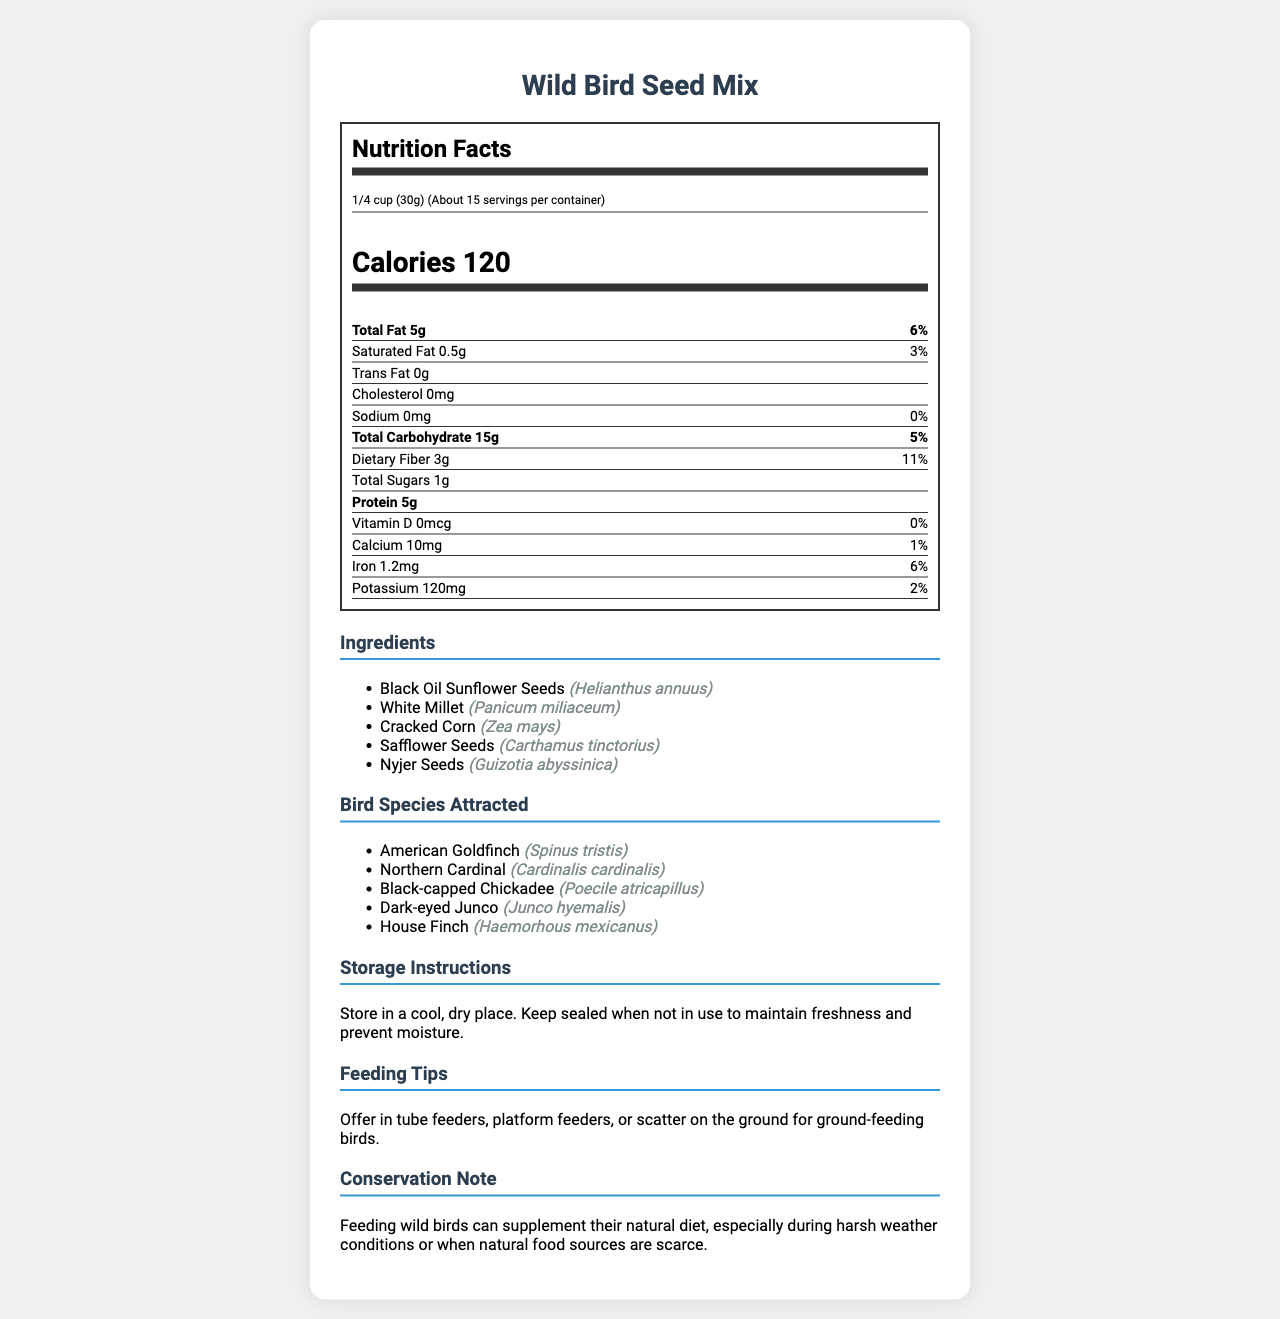what is the serving size of the Wild Bird Seed Mix? The serving size is listed at the top of the nutrition facts section.
Answer: 1/4 cup (30g) how many calories are in one serving? The calorie information is prominently displayed below the serving size and servings per container.
Answer: 120 what is the total fat content per serving? The total fat content is listed in the nutrition facts section under the calories.
Answer: 5g which ingredient is botanically known as Helianthus annuus? The scientific name Helianthus annuus corresponds to Black Oil Sunflower Seeds in the ingredients list.
Answer: Black Oil Sunflower Seeds how much protein does each serving contain? The protein content is listed towards the bottom of the nutrition facts section.
Answer: 5g which bird species is known scientifically as Spinus tristis? A. Northern Cardinal B. Dark-eyed Junco C. American Goldfinch D. House Finch The bird species section lists Spinus tristis as the scientific name for the American Goldfinch.
Answer: C. American Goldfinch how many milligrams of calcium are there per serving?  A. 10mg B. 15mg C. 20mg D. 25mg The calcium content is listed under the nutrition facts and is 10mg per serving.
Answer: A. 10mg does this bird seed mix attract Northern Cardinals? The bird species list includes Northern Cardinal with the scientific name Cardinalis cardinalis.
Answer: Yes describe the main idea of this document This document contains nutrition facts, serving size, ingredients list with scientific names, bird species attracted with scientific names, and usage instructions.
Answer: The main idea of the document is to provide an overview of the nutritional content, ingredients, bird species attracted, and usage instructions for the Wild Bird Seed Mix. which nutrient has the highest daily value percentage? The nutrient with the highest daily value percentage is listed under dietary fiber in the nutrition facts section.
Answer: Dietary Fiber (11%) what percentage of daily iron does one serving provide? The iron content percentage is listed under the nutrition facts section.
Answer: 6% what type of feeder is recommended for this bird seed mix? The feeding tips section suggests using tube feeders, platform feeders, or scattering the seeds on the ground.
Answer: Tube feeders, platform feeders, or scatter on the ground is there any trans fat in the Wild Bird Seed Mix? The trans fat content is listed as 0g in the nutrition facts section.
Answer: No which bird species is not attracted by this seed mix? The document only lists bird species that are attracted but doesn’t specify which species are not attracted.
Answer: Cannot be determined how will feeding wild birds from this mix contribute during harsh weather conditions? The conservation note explains that feeding wild birds can supplement their natural diet, especially during harsh weather conditions or when natural food sources are scarce.
Answer: Supplements their natural diet 